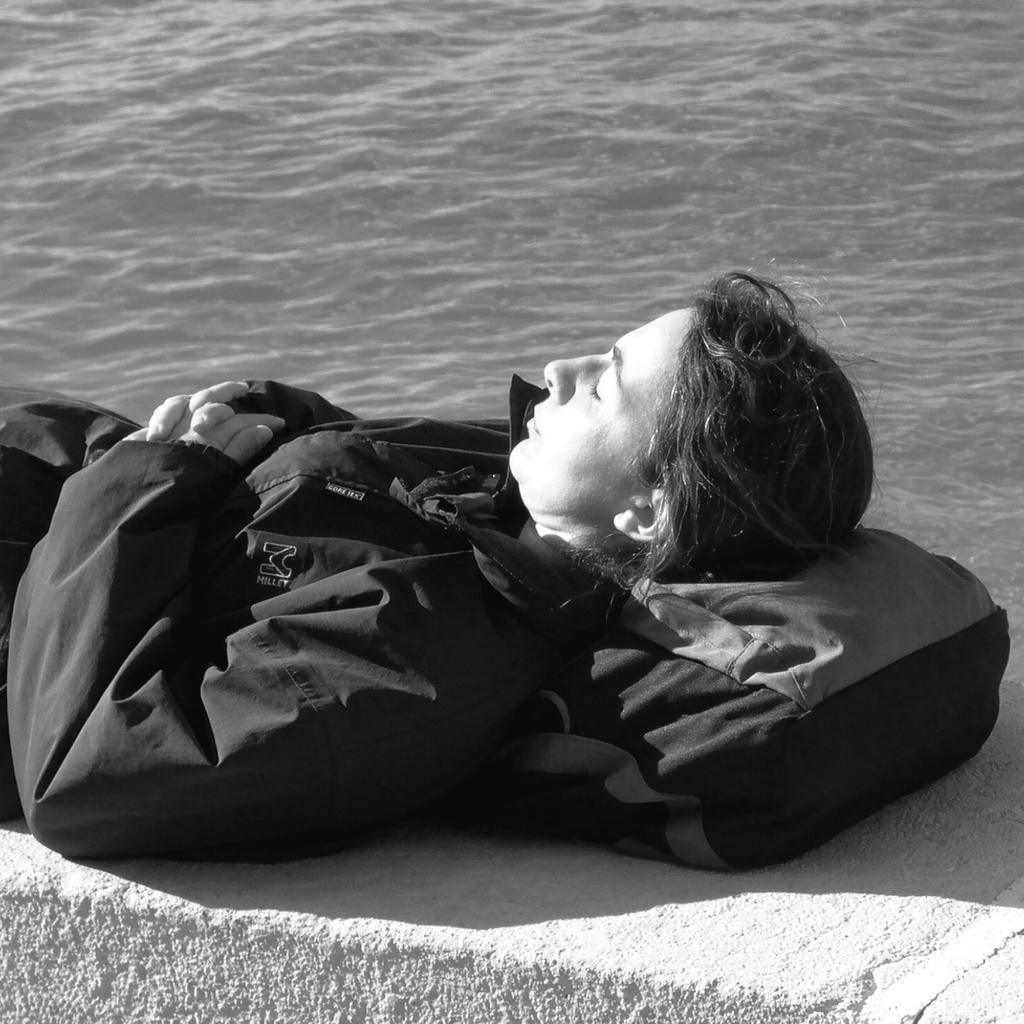Could you give a brief overview of what you see in this image? This is black and white image, in this image a person is sleeping on a small wall keeping bag under his head, in the background there is a river. 